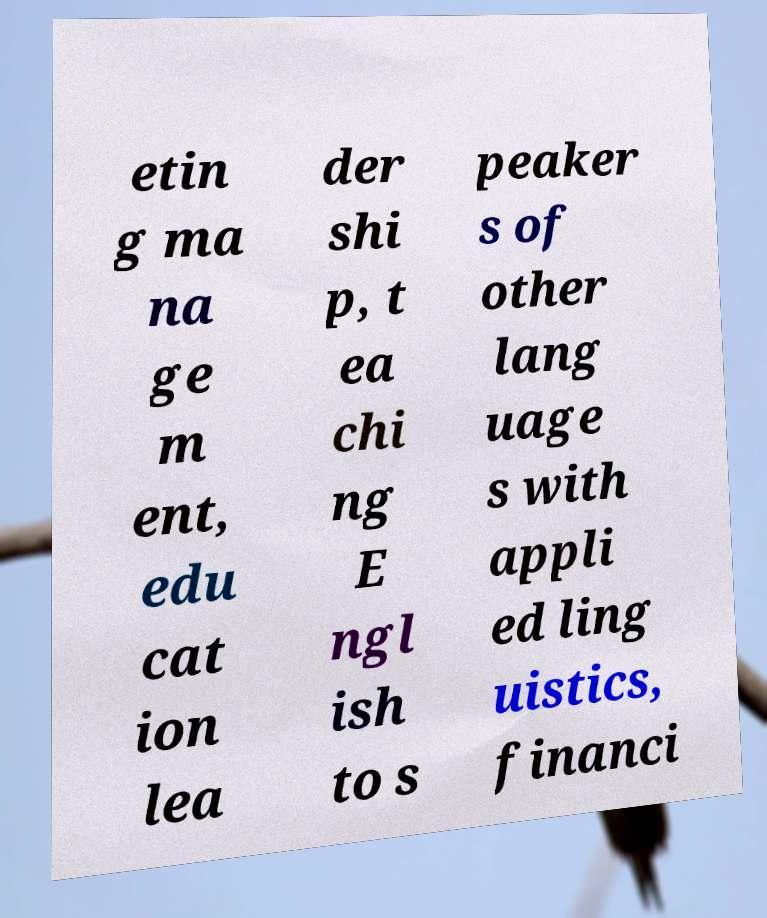Please identify and transcribe the text found in this image. etin g ma na ge m ent, edu cat ion lea der shi p, t ea chi ng E ngl ish to s peaker s of other lang uage s with appli ed ling uistics, financi 